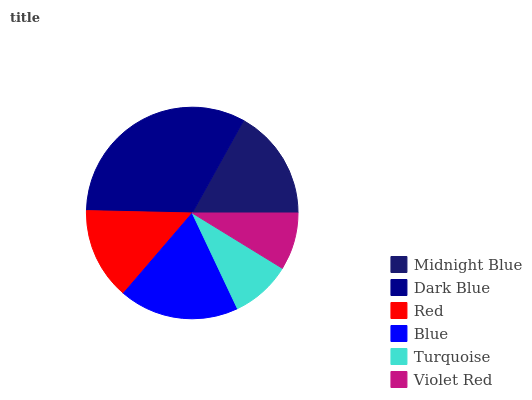Is Violet Red the minimum?
Answer yes or no. Yes. Is Dark Blue the maximum?
Answer yes or no. Yes. Is Red the minimum?
Answer yes or no. No. Is Red the maximum?
Answer yes or no. No. Is Dark Blue greater than Red?
Answer yes or no. Yes. Is Red less than Dark Blue?
Answer yes or no. Yes. Is Red greater than Dark Blue?
Answer yes or no. No. Is Dark Blue less than Red?
Answer yes or no. No. Is Midnight Blue the high median?
Answer yes or no. Yes. Is Red the low median?
Answer yes or no. Yes. Is Turquoise the high median?
Answer yes or no. No. Is Dark Blue the low median?
Answer yes or no. No. 